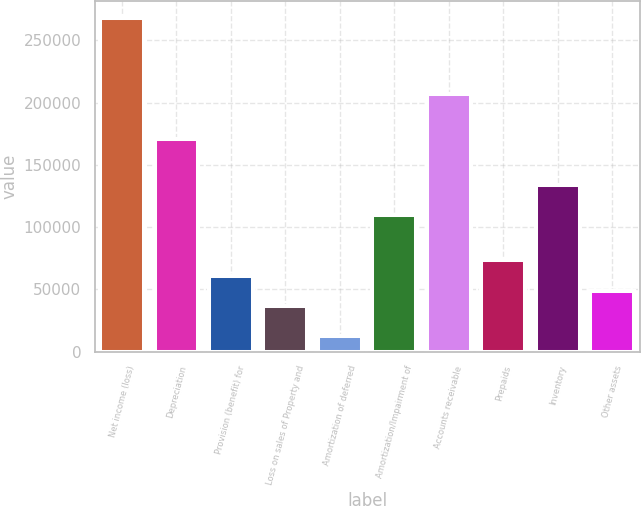<chart> <loc_0><loc_0><loc_500><loc_500><bar_chart><fcel>Net income (loss)<fcel>Depreciation<fcel>Provision (benefit) for<fcel>Loss on sales of Property and<fcel>Amortization of deferred<fcel>Amortization/Impairment of<fcel>Accounts receivable<fcel>Prepaids<fcel>Inventory<fcel>Other assets<nl><fcel>268049<fcel>170610<fcel>60990.5<fcel>36630.7<fcel>12270.9<fcel>109710<fcel>207149<fcel>73170.4<fcel>134070<fcel>48810.6<nl></chart> 